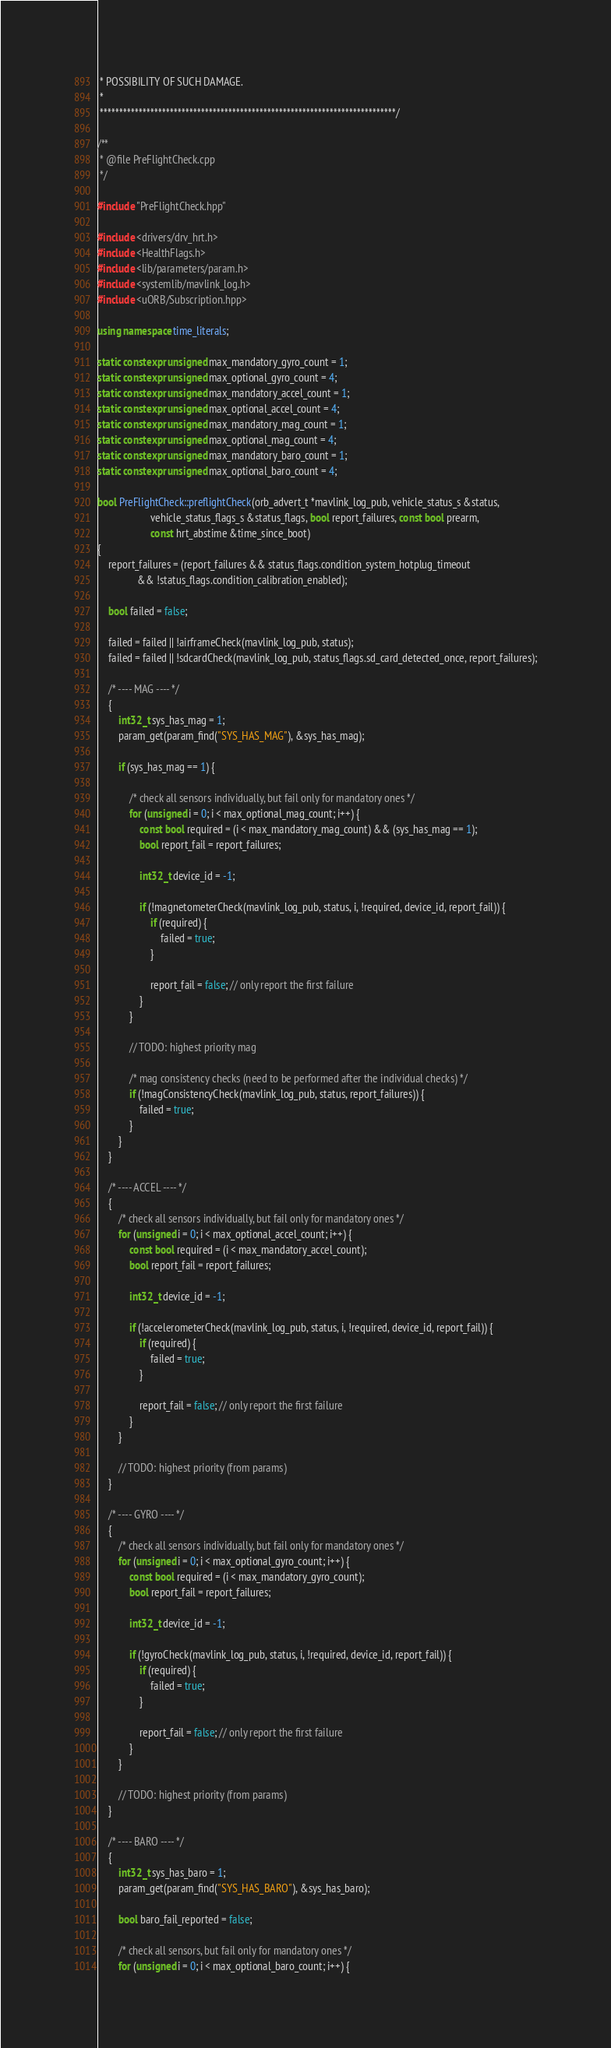<code> <loc_0><loc_0><loc_500><loc_500><_C++_> * POSSIBILITY OF SUCH DAMAGE.
 *
 ****************************************************************************/

/**
 * @file PreFlightCheck.cpp
 */

#include "PreFlightCheck.hpp"

#include <drivers/drv_hrt.h>
#include <HealthFlags.h>
#include <lib/parameters/param.h>
#include <systemlib/mavlink_log.h>
#include <uORB/Subscription.hpp>

using namespace time_literals;

static constexpr unsigned max_mandatory_gyro_count = 1;
static constexpr unsigned max_optional_gyro_count = 4;
static constexpr unsigned max_mandatory_accel_count = 1;
static constexpr unsigned max_optional_accel_count = 4;
static constexpr unsigned max_mandatory_mag_count = 1;
static constexpr unsigned max_optional_mag_count = 4;
static constexpr unsigned max_mandatory_baro_count = 1;
static constexpr unsigned max_optional_baro_count = 4;

bool PreFlightCheck::preflightCheck(orb_advert_t *mavlink_log_pub, vehicle_status_s &status,
				    vehicle_status_flags_s &status_flags, bool report_failures, const bool prearm,
				    const hrt_abstime &time_since_boot)
{
	report_failures = (report_failures && status_flags.condition_system_hotplug_timeout
			   && !status_flags.condition_calibration_enabled);

	bool failed = false;

	failed = failed || !airframeCheck(mavlink_log_pub, status);
	failed = failed || !sdcardCheck(mavlink_log_pub, status_flags.sd_card_detected_once, report_failures);

	/* ---- MAG ---- */
	{
		int32_t sys_has_mag = 1;
		param_get(param_find("SYS_HAS_MAG"), &sys_has_mag);

		if (sys_has_mag == 1) {

			/* check all sensors individually, but fail only for mandatory ones */
			for (unsigned i = 0; i < max_optional_mag_count; i++) {
				const bool required = (i < max_mandatory_mag_count) && (sys_has_mag == 1);
				bool report_fail = report_failures;

				int32_t device_id = -1;

				if (!magnetometerCheck(mavlink_log_pub, status, i, !required, device_id, report_fail)) {
					if (required) {
						failed = true;
					}

					report_fail = false; // only report the first failure
				}
			}

			// TODO: highest priority mag

			/* mag consistency checks (need to be performed after the individual checks) */
			if (!magConsistencyCheck(mavlink_log_pub, status, report_failures)) {
				failed = true;
			}
		}
	}

	/* ---- ACCEL ---- */
	{
		/* check all sensors individually, but fail only for mandatory ones */
		for (unsigned i = 0; i < max_optional_accel_count; i++) {
			const bool required = (i < max_mandatory_accel_count);
			bool report_fail = report_failures;

			int32_t device_id = -1;

			if (!accelerometerCheck(mavlink_log_pub, status, i, !required, device_id, report_fail)) {
				if (required) {
					failed = true;
				}

				report_fail = false; // only report the first failure
			}
		}

		// TODO: highest priority (from params)
	}

	/* ---- GYRO ---- */
	{
		/* check all sensors individually, but fail only for mandatory ones */
		for (unsigned i = 0; i < max_optional_gyro_count; i++) {
			const bool required = (i < max_mandatory_gyro_count);
			bool report_fail = report_failures;

			int32_t device_id = -1;

			if (!gyroCheck(mavlink_log_pub, status, i, !required, device_id, report_fail)) {
				if (required) {
					failed = true;
				}

				report_fail = false; // only report the first failure
			}
		}

		// TODO: highest priority (from params)
	}

	/* ---- BARO ---- */
	{
		int32_t sys_has_baro = 1;
		param_get(param_find("SYS_HAS_BARO"), &sys_has_baro);

		bool baro_fail_reported = false;

		/* check all sensors, but fail only for mandatory ones */
		for (unsigned i = 0; i < max_optional_baro_count; i++) {</code> 